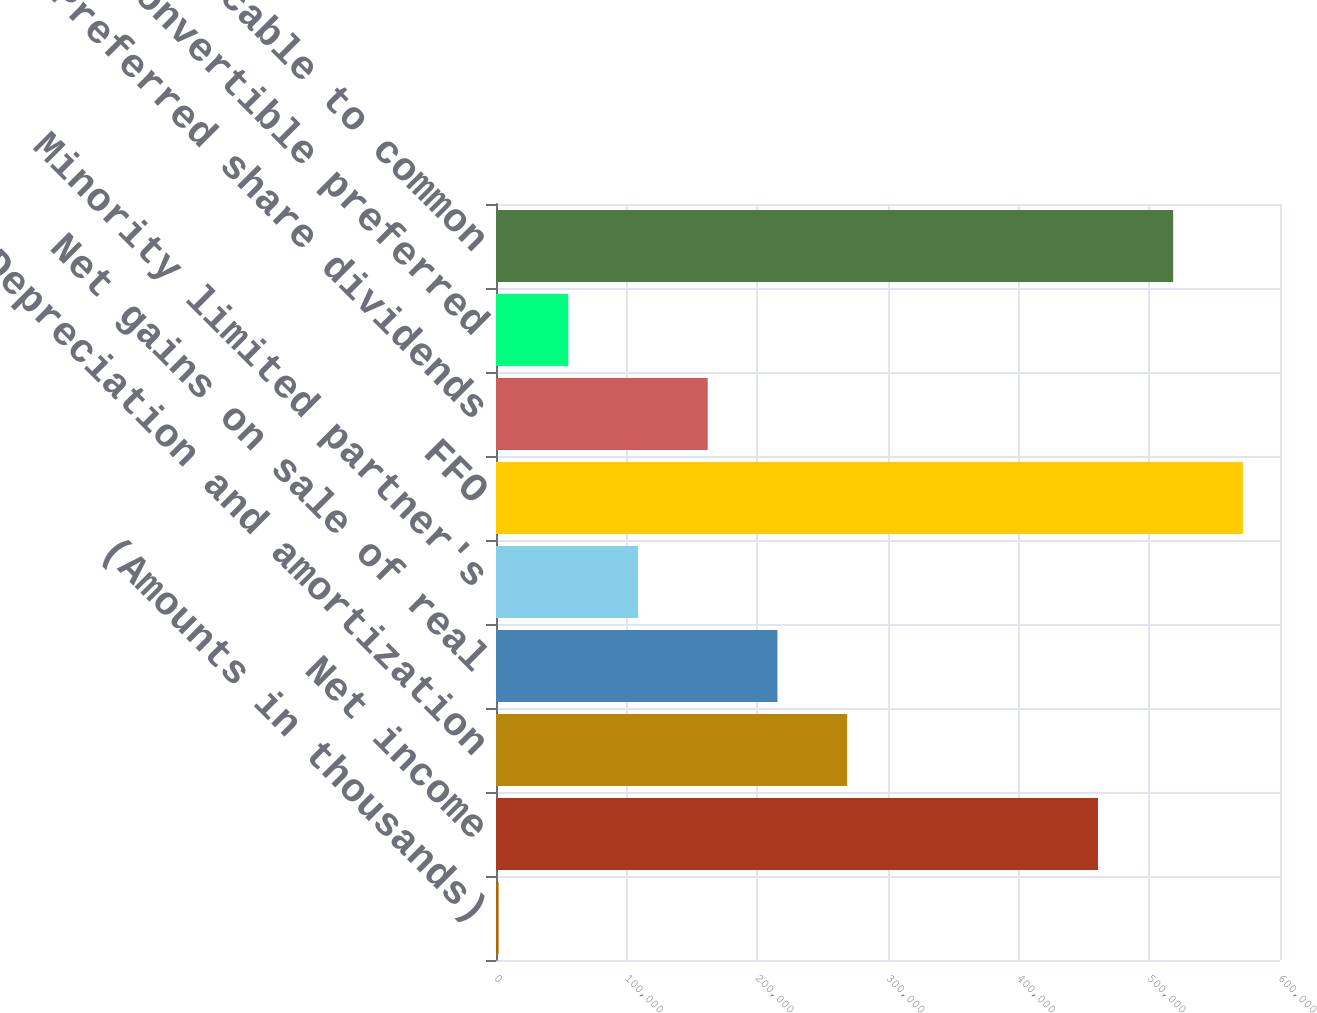Convert chart to OTSL. <chart><loc_0><loc_0><loc_500><loc_500><bar_chart><fcel>(Amounts in thousands)<fcel>Net income<fcel>Depreciation and amortization<fcel>Net gains on sale of real<fcel>Minority limited partner's<fcel>FFO<fcel>Preferred share dividends<fcel>Series A convertible preferred<fcel>FFO applicable to common<nl><fcel>2003<fcel>460703<fcel>268745<fcel>215397<fcel>108700<fcel>571590<fcel>162048<fcel>55351.4<fcel>518242<nl></chart> 